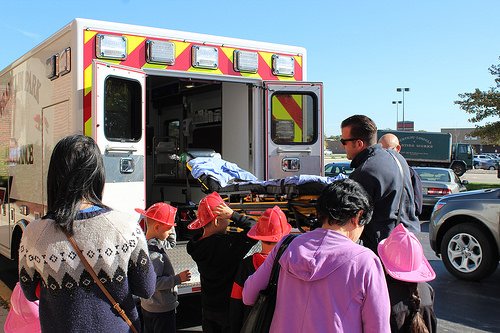<image>
Is there a ambulance in front of the woman? Yes. The ambulance is positioned in front of the woman, appearing closer to the camera viewpoint. 